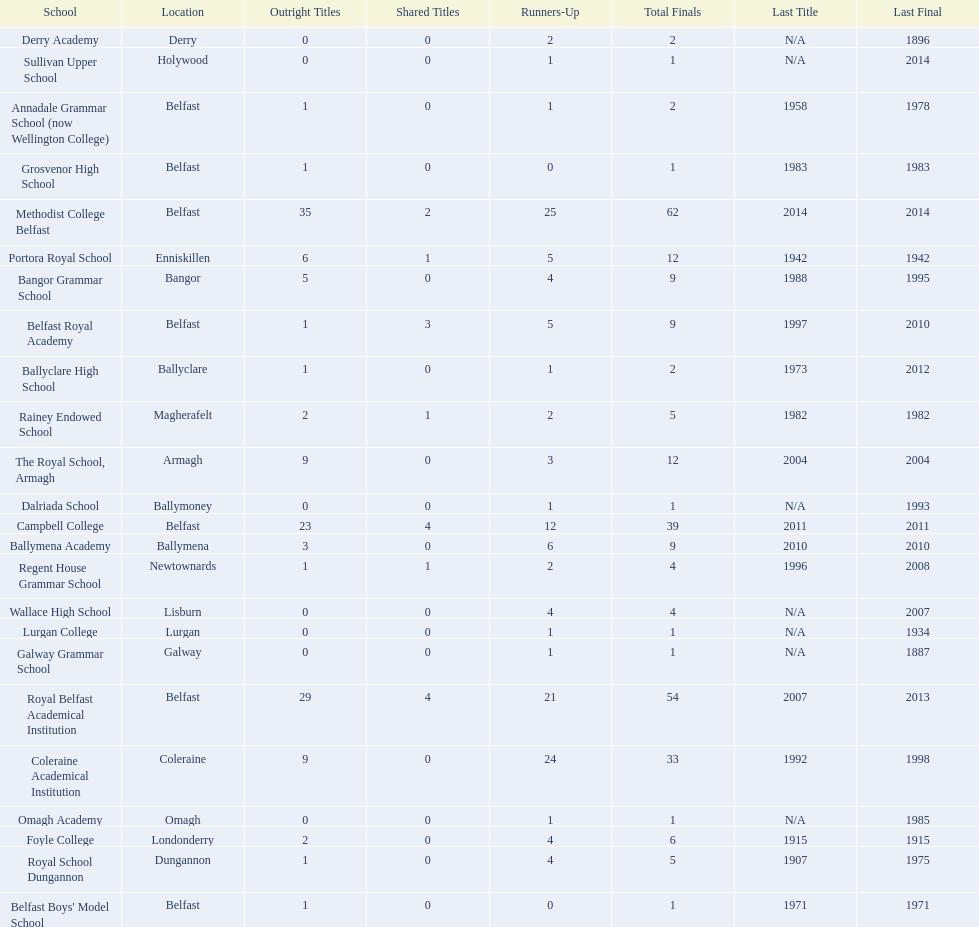What were all of the school names? Methodist College Belfast, Royal Belfast Academical Institution, Campbell College, Coleraine Academical Institution, The Royal School, Armagh, Portora Royal School, Bangor Grammar School, Ballymena Academy, Rainey Endowed School, Foyle College, Belfast Royal Academy, Regent House Grammar School, Royal School Dungannon, Annadale Grammar School (now Wellington College), Ballyclare High School, Belfast Boys' Model School, Grosvenor High School, Wallace High School, Derry Academy, Dalriada School, Galway Grammar School, Lurgan College, Omagh Academy, Sullivan Upper School. How many outright titles did they achieve? 35, 29, 23, 9, 9, 6, 5, 3, 2, 2, 1, 1, 1, 1, 1, 1, 1, 0, 0, 0, 0, 0, 0, 0. And how many did coleraine academical institution receive? 9. Which other school had the same number of outright titles? The Royal School, Armagh. 